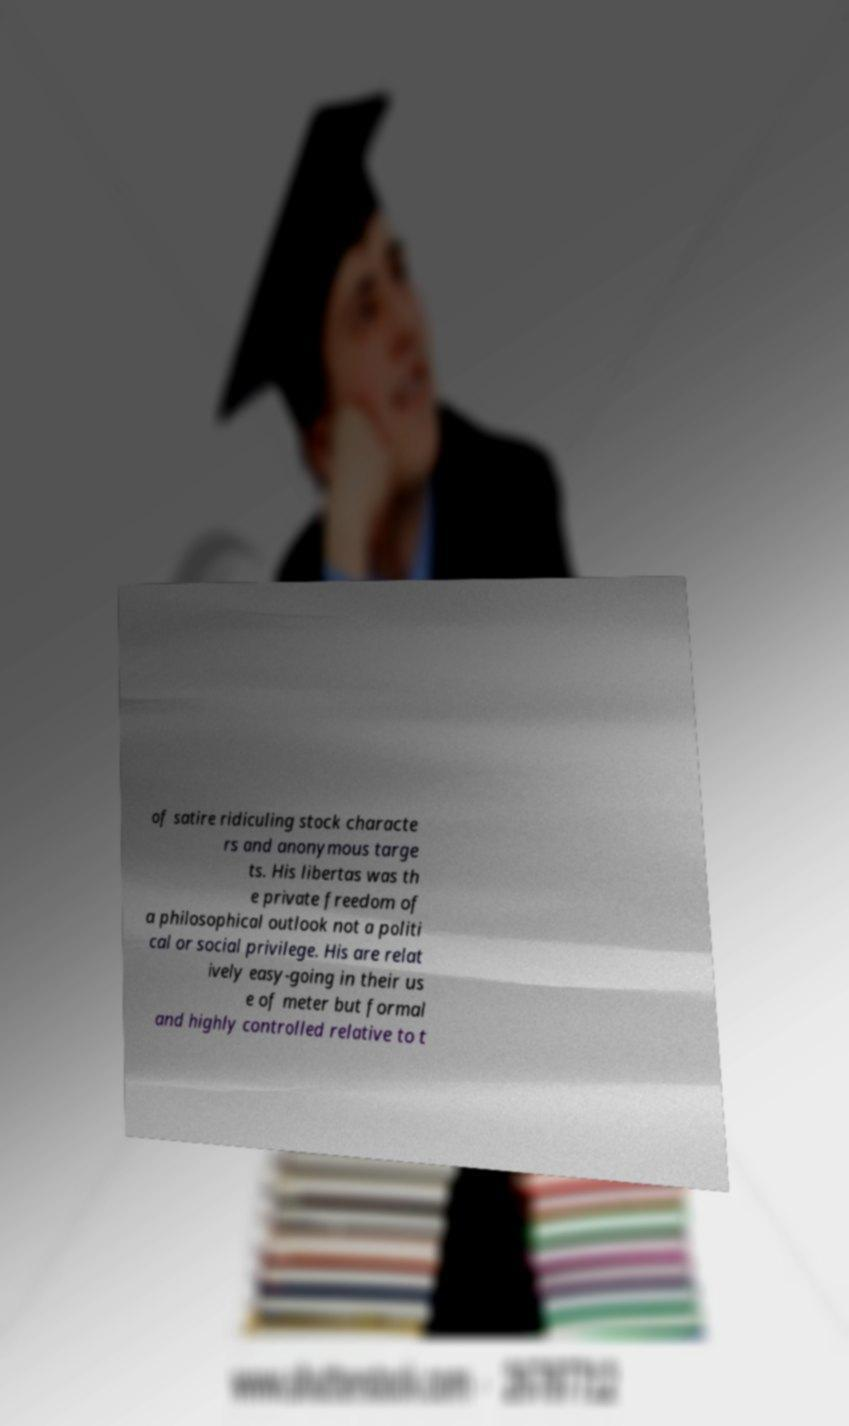Can you accurately transcribe the text from the provided image for me? of satire ridiculing stock characte rs and anonymous targe ts. His libertas was th e private freedom of a philosophical outlook not a politi cal or social privilege. His are relat ively easy-going in their us e of meter but formal and highly controlled relative to t 